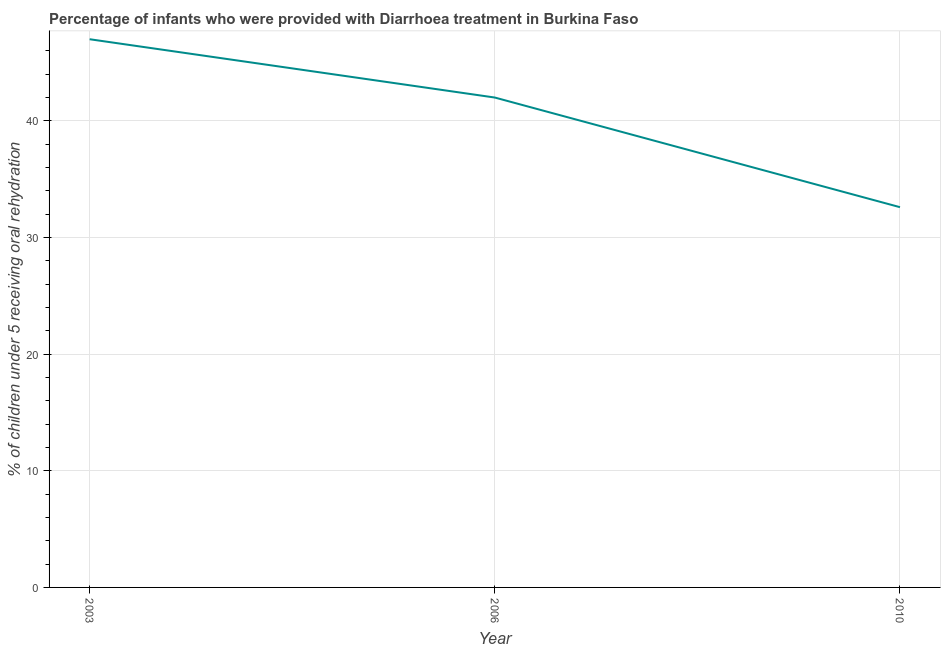What is the percentage of children who were provided with treatment diarrhoea in 2006?
Your answer should be very brief. 42. Across all years, what is the maximum percentage of children who were provided with treatment diarrhoea?
Your response must be concise. 47. Across all years, what is the minimum percentage of children who were provided with treatment diarrhoea?
Keep it short and to the point. 32.6. In which year was the percentage of children who were provided with treatment diarrhoea maximum?
Provide a succinct answer. 2003. What is the sum of the percentage of children who were provided with treatment diarrhoea?
Provide a succinct answer. 121.6. What is the average percentage of children who were provided with treatment diarrhoea per year?
Make the answer very short. 40.53. What is the median percentage of children who were provided with treatment diarrhoea?
Provide a short and direct response. 42. In how many years, is the percentage of children who were provided with treatment diarrhoea greater than 22 %?
Offer a terse response. 3. Do a majority of the years between 2010 and 2003 (inclusive) have percentage of children who were provided with treatment diarrhoea greater than 28 %?
Provide a succinct answer. No. What is the ratio of the percentage of children who were provided with treatment diarrhoea in 2003 to that in 2010?
Provide a short and direct response. 1.44. What is the difference between the highest and the second highest percentage of children who were provided with treatment diarrhoea?
Keep it short and to the point. 5. Is the sum of the percentage of children who were provided with treatment diarrhoea in 2003 and 2010 greater than the maximum percentage of children who were provided with treatment diarrhoea across all years?
Your answer should be compact. Yes. What is the difference between the highest and the lowest percentage of children who were provided with treatment diarrhoea?
Provide a short and direct response. 14.4. In how many years, is the percentage of children who were provided with treatment diarrhoea greater than the average percentage of children who were provided with treatment diarrhoea taken over all years?
Your response must be concise. 2. Does the percentage of children who were provided with treatment diarrhoea monotonically increase over the years?
Offer a very short reply. No. How many years are there in the graph?
Give a very brief answer. 3. What is the difference between two consecutive major ticks on the Y-axis?
Offer a terse response. 10. Are the values on the major ticks of Y-axis written in scientific E-notation?
Your answer should be very brief. No. What is the title of the graph?
Offer a very short reply. Percentage of infants who were provided with Diarrhoea treatment in Burkina Faso. What is the label or title of the Y-axis?
Give a very brief answer. % of children under 5 receiving oral rehydration. What is the % of children under 5 receiving oral rehydration in 2003?
Your answer should be very brief. 47. What is the % of children under 5 receiving oral rehydration in 2006?
Give a very brief answer. 42. What is the % of children under 5 receiving oral rehydration in 2010?
Offer a terse response. 32.6. What is the difference between the % of children under 5 receiving oral rehydration in 2003 and 2010?
Ensure brevity in your answer.  14.4. What is the difference between the % of children under 5 receiving oral rehydration in 2006 and 2010?
Offer a terse response. 9.4. What is the ratio of the % of children under 5 receiving oral rehydration in 2003 to that in 2006?
Your answer should be very brief. 1.12. What is the ratio of the % of children under 5 receiving oral rehydration in 2003 to that in 2010?
Provide a succinct answer. 1.44. What is the ratio of the % of children under 5 receiving oral rehydration in 2006 to that in 2010?
Your response must be concise. 1.29. 